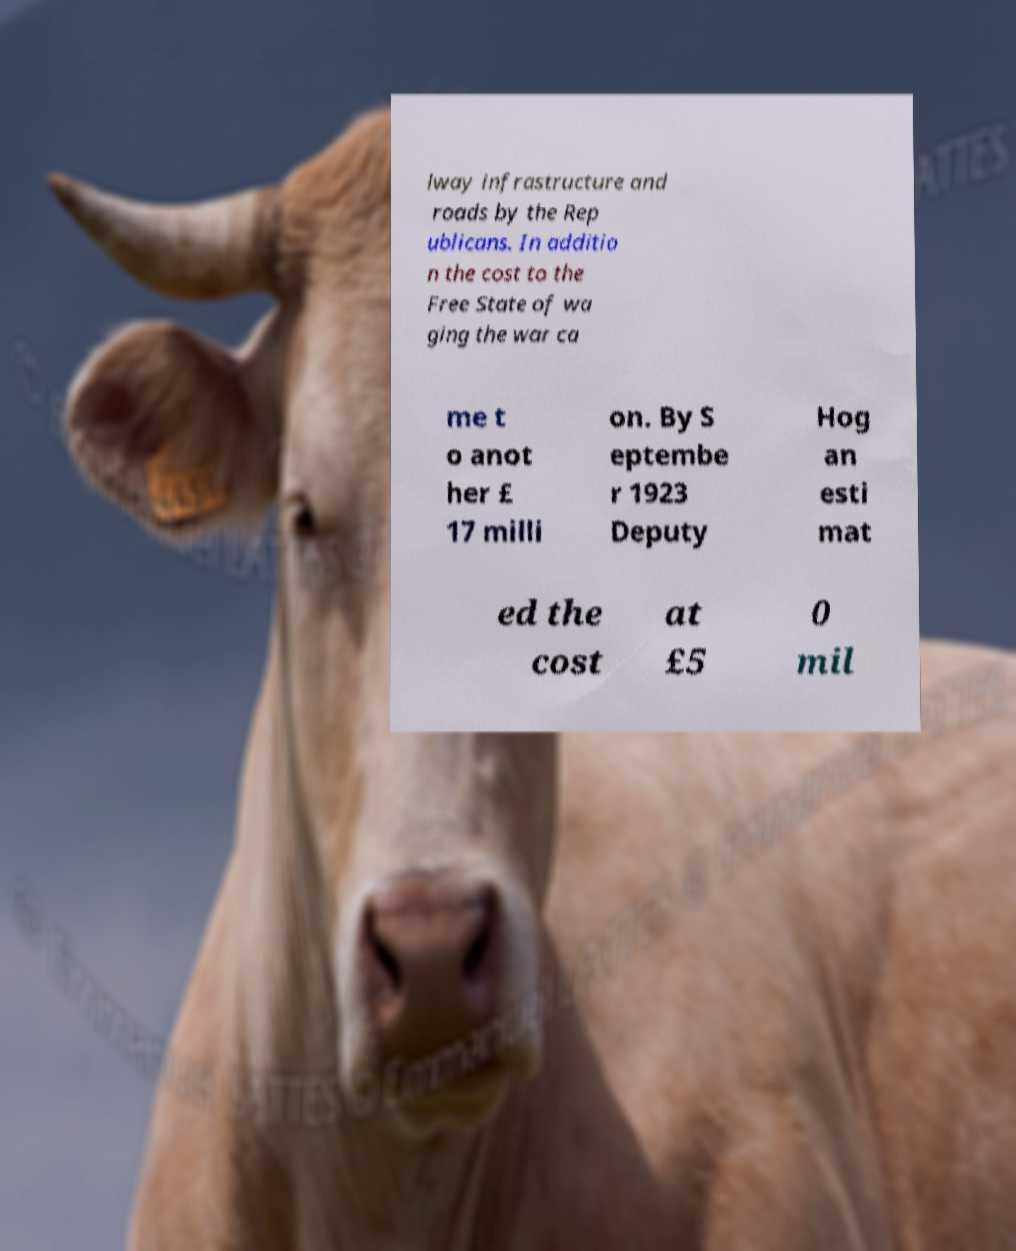Please read and relay the text visible in this image. What does it say? lway infrastructure and roads by the Rep ublicans. In additio n the cost to the Free State of wa ging the war ca me t o anot her £ 17 milli on. By S eptembe r 1923 Deputy Hog an esti mat ed the cost at £5 0 mil 